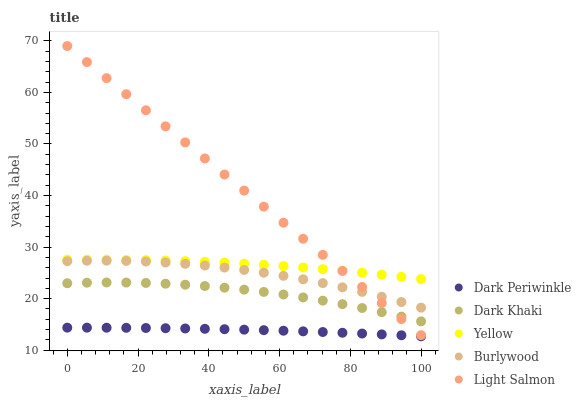Does Dark Periwinkle have the minimum area under the curve?
Answer yes or no. Yes. Does Light Salmon have the maximum area under the curve?
Answer yes or no. Yes. Does Burlywood have the minimum area under the curve?
Answer yes or no. No. Does Burlywood have the maximum area under the curve?
Answer yes or no. No. Is Light Salmon the smoothest?
Answer yes or no. Yes. Is Burlywood the roughest?
Answer yes or no. Yes. Is Burlywood the smoothest?
Answer yes or no. No. Is Light Salmon the roughest?
Answer yes or no. No. Does Dark Periwinkle have the lowest value?
Answer yes or no. Yes. Does Burlywood have the lowest value?
Answer yes or no. No. Does Light Salmon have the highest value?
Answer yes or no. Yes. Does Burlywood have the highest value?
Answer yes or no. No. Is Dark Khaki less than Yellow?
Answer yes or no. Yes. Is Yellow greater than Dark Periwinkle?
Answer yes or no. Yes. Does Light Salmon intersect Burlywood?
Answer yes or no. Yes. Is Light Salmon less than Burlywood?
Answer yes or no. No. Is Light Salmon greater than Burlywood?
Answer yes or no. No. Does Dark Khaki intersect Yellow?
Answer yes or no. No. 